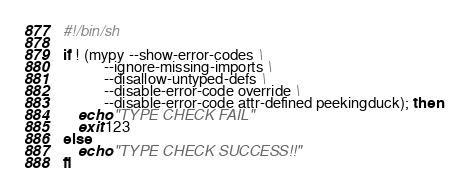<code> <loc_0><loc_0><loc_500><loc_500><_Bash_>#!/bin/sh

if ! (mypy --show-error-codes \
           --ignore-missing-imports \
           --disallow-untyped-defs \
           --disable-error-code override \
           --disable-error-code attr-defined peekingduck); then
    echo "TYPE CHECK FAIL"
    exit 123
else
    echo "TYPE CHECK SUCCESS!!"
fi</code> 